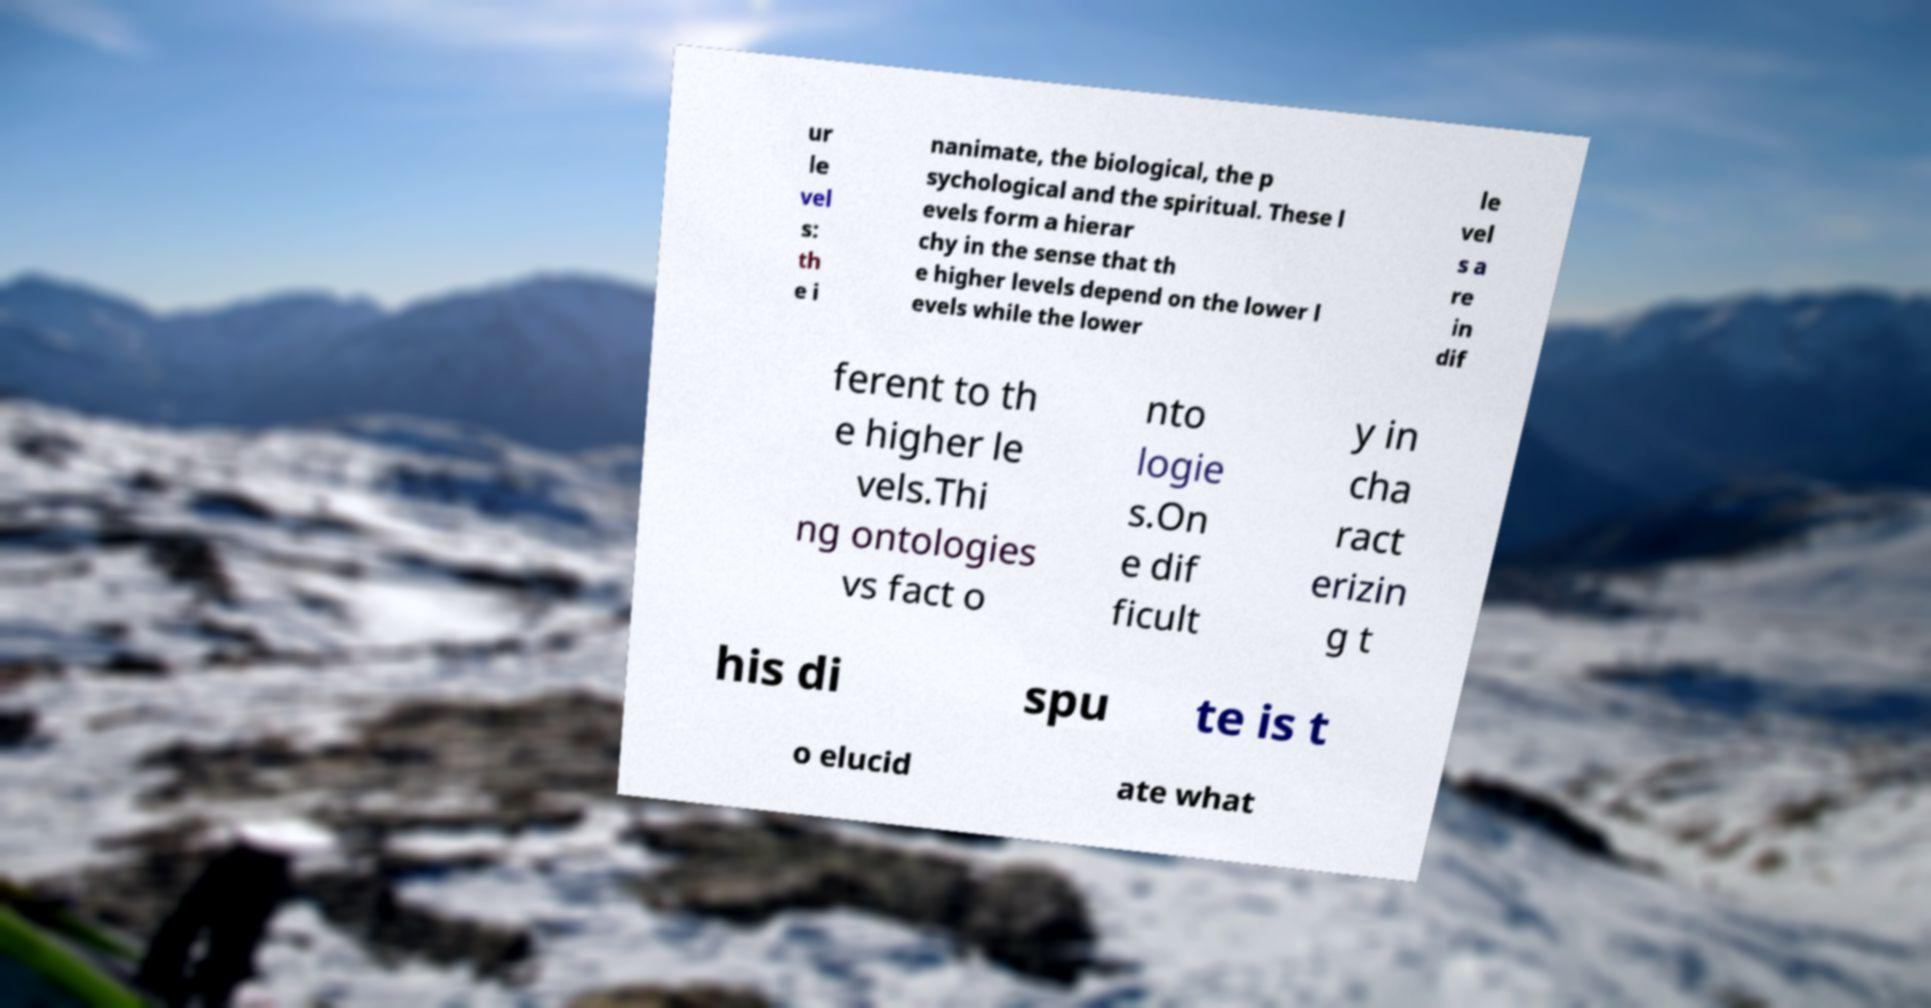For documentation purposes, I need the text within this image transcribed. Could you provide that? ur le vel s: th e i nanimate, the biological, the p sychological and the spiritual. These l evels form a hierar chy in the sense that th e higher levels depend on the lower l evels while the lower le vel s a re in dif ferent to th e higher le vels.Thi ng ontologies vs fact o nto logie s.On e dif ficult y in cha ract erizin g t his di spu te is t o elucid ate what 